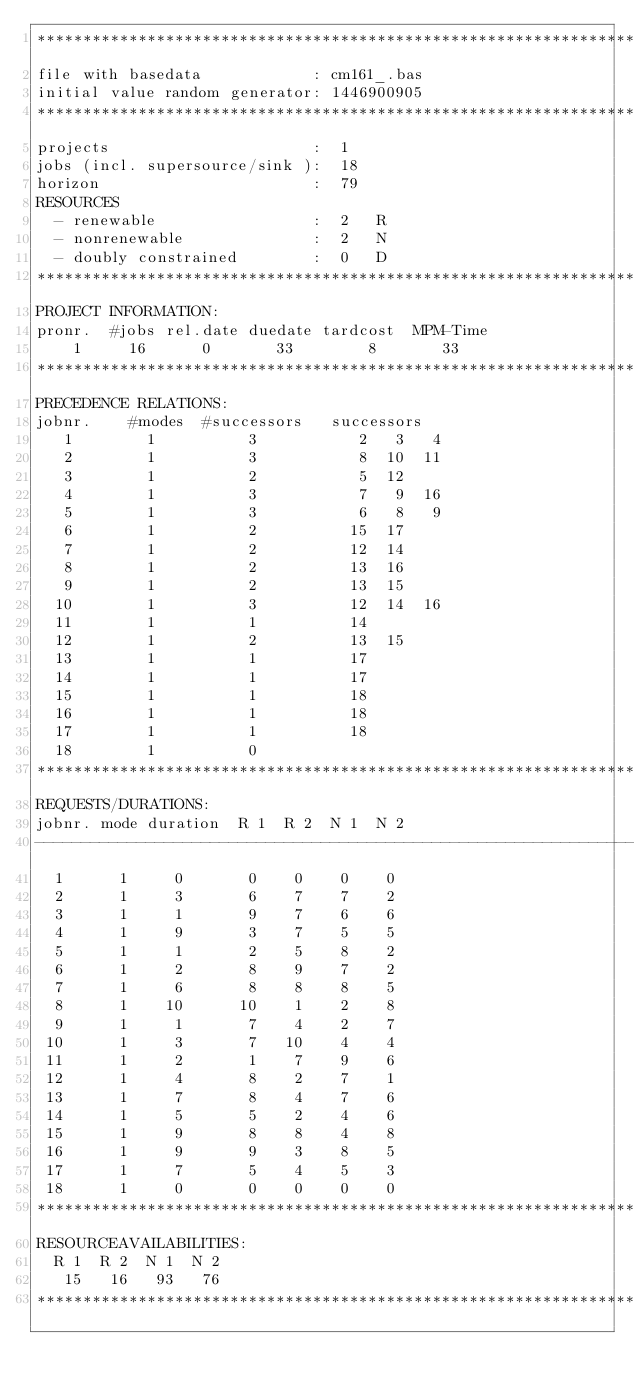<code> <loc_0><loc_0><loc_500><loc_500><_ObjectiveC_>************************************************************************
file with basedata            : cm161_.bas
initial value random generator: 1446900905
************************************************************************
projects                      :  1
jobs (incl. supersource/sink ):  18
horizon                       :  79
RESOURCES
  - renewable                 :  2   R
  - nonrenewable              :  2   N
  - doubly constrained        :  0   D
************************************************************************
PROJECT INFORMATION:
pronr.  #jobs rel.date duedate tardcost  MPM-Time
    1     16      0       33        8       33
************************************************************************
PRECEDENCE RELATIONS:
jobnr.    #modes  #successors   successors
   1        1          3           2   3   4
   2        1          3           8  10  11
   3        1          2           5  12
   4        1          3           7   9  16
   5        1          3           6   8   9
   6        1          2          15  17
   7        1          2          12  14
   8        1          2          13  16
   9        1          2          13  15
  10        1          3          12  14  16
  11        1          1          14
  12        1          2          13  15
  13        1          1          17
  14        1          1          17
  15        1          1          18
  16        1          1          18
  17        1          1          18
  18        1          0        
************************************************************************
REQUESTS/DURATIONS:
jobnr. mode duration  R 1  R 2  N 1  N 2
------------------------------------------------------------------------
  1      1     0       0    0    0    0
  2      1     3       6    7    7    2
  3      1     1       9    7    6    6
  4      1     9       3    7    5    5
  5      1     1       2    5    8    2
  6      1     2       8    9    7    2
  7      1     6       8    8    8    5
  8      1    10      10    1    2    8
  9      1     1       7    4    2    7
 10      1     3       7   10    4    4
 11      1     2       1    7    9    6
 12      1     4       8    2    7    1
 13      1     7       8    4    7    6
 14      1     5       5    2    4    6
 15      1     9       8    8    4    8
 16      1     9       9    3    8    5
 17      1     7       5    4    5    3
 18      1     0       0    0    0    0
************************************************************************
RESOURCEAVAILABILITIES:
  R 1  R 2  N 1  N 2
   15   16   93   76
************************************************************************
</code> 